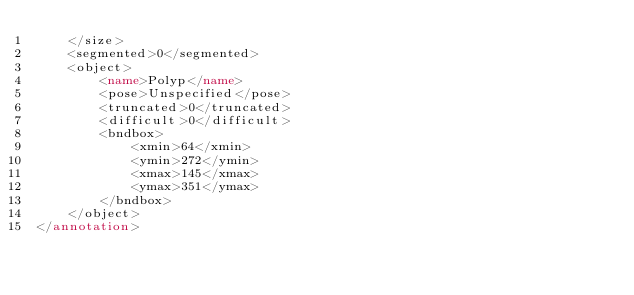<code> <loc_0><loc_0><loc_500><loc_500><_XML_>    </size>
    <segmented>0</segmented>
    <object>
        <name>Polyp</name>
        <pose>Unspecified</pose>
        <truncated>0</truncated>
        <difficult>0</difficult>
        <bndbox>
            <xmin>64</xmin>
            <ymin>272</ymin>
            <xmax>145</xmax>
            <ymax>351</ymax>
        </bndbox>
    </object>
</annotation>
</code> 